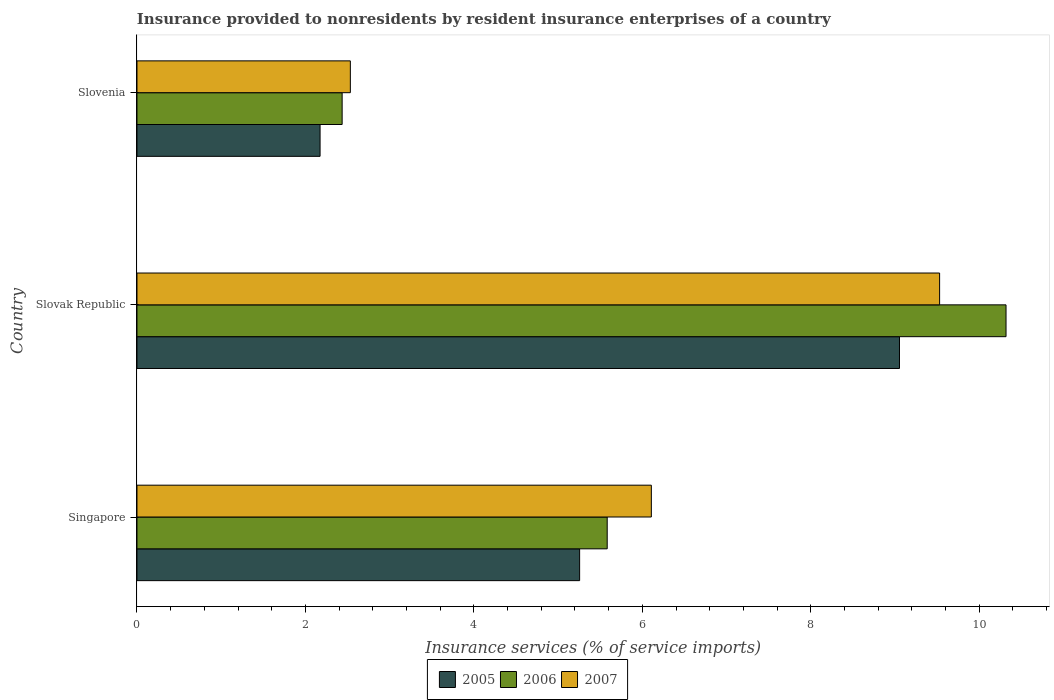How many different coloured bars are there?
Offer a very short reply. 3. How many groups of bars are there?
Ensure brevity in your answer.  3. How many bars are there on the 2nd tick from the top?
Provide a succinct answer. 3. What is the label of the 2nd group of bars from the top?
Offer a very short reply. Slovak Republic. In how many cases, is the number of bars for a given country not equal to the number of legend labels?
Make the answer very short. 0. What is the insurance provided to nonresidents in 2006 in Slovenia?
Your answer should be compact. 2.44. Across all countries, what is the maximum insurance provided to nonresidents in 2005?
Your answer should be compact. 9.05. Across all countries, what is the minimum insurance provided to nonresidents in 2005?
Provide a short and direct response. 2.17. In which country was the insurance provided to nonresidents in 2006 maximum?
Give a very brief answer. Slovak Republic. In which country was the insurance provided to nonresidents in 2006 minimum?
Your response must be concise. Slovenia. What is the total insurance provided to nonresidents in 2007 in the graph?
Ensure brevity in your answer.  18.17. What is the difference between the insurance provided to nonresidents in 2005 in Singapore and that in Slovenia?
Ensure brevity in your answer.  3.08. What is the difference between the insurance provided to nonresidents in 2006 in Singapore and the insurance provided to nonresidents in 2007 in Slovenia?
Offer a very short reply. 3.05. What is the average insurance provided to nonresidents in 2007 per country?
Ensure brevity in your answer.  6.06. What is the difference between the insurance provided to nonresidents in 2007 and insurance provided to nonresidents in 2006 in Slovak Republic?
Your answer should be very brief. -0.79. What is the ratio of the insurance provided to nonresidents in 2005 in Slovak Republic to that in Slovenia?
Provide a short and direct response. 4.16. Is the difference between the insurance provided to nonresidents in 2007 in Singapore and Slovenia greater than the difference between the insurance provided to nonresidents in 2006 in Singapore and Slovenia?
Give a very brief answer. Yes. What is the difference between the highest and the second highest insurance provided to nonresidents in 2006?
Provide a short and direct response. 4.74. What is the difference between the highest and the lowest insurance provided to nonresidents in 2005?
Offer a very short reply. 6.88. Is the sum of the insurance provided to nonresidents in 2007 in Singapore and Slovak Republic greater than the maximum insurance provided to nonresidents in 2006 across all countries?
Your answer should be compact. Yes. What does the 2nd bar from the top in Singapore represents?
Offer a terse response. 2006. What does the 3rd bar from the bottom in Slovak Republic represents?
Offer a very short reply. 2007. Where does the legend appear in the graph?
Ensure brevity in your answer.  Bottom center. How many legend labels are there?
Offer a very short reply. 3. How are the legend labels stacked?
Offer a terse response. Horizontal. What is the title of the graph?
Give a very brief answer. Insurance provided to nonresidents by resident insurance enterprises of a country. Does "2005" appear as one of the legend labels in the graph?
Your answer should be compact. Yes. What is the label or title of the X-axis?
Keep it short and to the point. Insurance services (% of service imports). What is the Insurance services (% of service imports) of 2005 in Singapore?
Ensure brevity in your answer.  5.26. What is the Insurance services (% of service imports) of 2006 in Singapore?
Provide a succinct answer. 5.58. What is the Insurance services (% of service imports) in 2007 in Singapore?
Provide a succinct answer. 6.11. What is the Insurance services (% of service imports) of 2005 in Slovak Republic?
Provide a short and direct response. 9.05. What is the Insurance services (% of service imports) in 2006 in Slovak Republic?
Your answer should be very brief. 10.32. What is the Insurance services (% of service imports) of 2007 in Slovak Republic?
Make the answer very short. 9.53. What is the Insurance services (% of service imports) of 2005 in Slovenia?
Ensure brevity in your answer.  2.17. What is the Insurance services (% of service imports) in 2006 in Slovenia?
Ensure brevity in your answer.  2.44. What is the Insurance services (% of service imports) of 2007 in Slovenia?
Provide a succinct answer. 2.53. Across all countries, what is the maximum Insurance services (% of service imports) of 2005?
Provide a short and direct response. 9.05. Across all countries, what is the maximum Insurance services (% of service imports) of 2006?
Ensure brevity in your answer.  10.32. Across all countries, what is the maximum Insurance services (% of service imports) of 2007?
Keep it short and to the point. 9.53. Across all countries, what is the minimum Insurance services (% of service imports) in 2005?
Give a very brief answer. 2.17. Across all countries, what is the minimum Insurance services (% of service imports) of 2006?
Your response must be concise. 2.44. Across all countries, what is the minimum Insurance services (% of service imports) in 2007?
Give a very brief answer. 2.53. What is the total Insurance services (% of service imports) of 2005 in the graph?
Offer a very short reply. 16.48. What is the total Insurance services (% of service imports) in 2006 in the graph?
Offer a terse response. 18.34. What is the total Insurance services (% of service imports) in 2007 in the graph?
Provide a succinct answer. 18.17. What is the difference between the Insurance services (% of service imports) in 2005 in Singapore and that in Slovak Republic?
Ensure brevity in your answer.  -3.8. What is the difference between the Insurance services (% of service imports) in 2006 in Singapore and that in Slovak Republic?
Your response must be concise. -4.74. What is the difference between the Insurance services (% of service imports) in 2007 in Singapore and that in Slovak Republic?
Keep it short and to the point. -3.42. What is the difference between the Insurance services (% of service imports) in 2005 in Singapore and that in Slovenia?
Provide a succinct answer. 3.08. What is the difference between the Insurance services (% of service imports) of 2006 in Singapore and that in Slovenia?
Your response must be concise. 3.15. What is the difference between the Insurance services (% of service imports) of 2007 in Singapore and that in Slovenia?
Your response must be concise. 3.57. What is the difference between the Insurance services (% of service imports) in 2005 in Slovak Republic and that in Slovenia?
Keep it short and to the point. 6.88. What is the difference between the Insurance services (% of service imports) of 2006 in Slovak Republic and that in Slovenia?
Make the answer very short. 7.88. What is the difference between the Insurance services (% of service imports) in 2007 in Slovak Republic and that in Slovenia?
Offer a very short reply. 7. What is the difference between the Insurance services (% of service imports) in 2005 in Singapore and the Insurance services (% of service imports) in 2006 in Slovak Republic?
Offer a terse response. -5.06. What is the difference between the Insurance services (% of service imports) in 2005 in Singapore and the Insurance services (% of service imports) in 2007 in Slovak Republic?
Ensure brevity in your answer.  -4.27. What is the difference between the Insurance services (% of service imports) of 2006 in Singapore and the Insurance services (% of service imports) of 2007 in Slovak Republic?
Offer a terse response. -3.95. What is the difference between the Insurance services (% of service imports) of 2005 in Singapore and the Insurance services (% of service imports) of 2006 in Slovenia?
Provide a short and direct response. 2.82. What is the difference between the Insurance services (% of service imports) in 2005 in Singapore and the Insurance services (% of service imports) in 2007 in Slovenia?
Provide a short and direct response. 2.72. What is the difference between the Insurance services (% of service imports) in 2006 in Singapore and the Insurance services (% of service imports) in 2007 in Slovenia?
Your answer should be very brief. 3.05. What is the difference between the Insurance services (% of service imports) in 2005 in Slovak Republic and the Insurance services (% of service imports) in 2006 in Slovenia?
Keep it short and to the point. 6.62. What is the difference between the Insurance services (% of service imports) in 2005 in Slovak Republic and the Insurance services (% of service imports) in 2007 in Slovenia?
Provide a short and direct response. 6.52. What is the difference between the Insurance services (% of service imports) in 2006 in Slovak Republic and the Insurance services (% of service imports) in 2007 in Slovenia?
Your response must be concise. 7.79. What is the average Insurance services (% of service imports) in 2005 per country?
Your answer should be compact. 5.49. What is the average Insurance services (% of service imports) of 2006 per country?
Provide a short and direct response. 6.11. What is the average Insurance services (% of service imports) in 2007 per country?
Your answer should be very brief. 6.06. What is the difference between the Insurance services (% of service imports) in 2005 and Insurance services (% of service imports) in 2006 in Singapore?
Your answer should be compact. -0.33. What is the difference between the Insurance services (% of service imports) of 2005 and Insurance services (% of service imports) of 2007 in Singapore?
Your response must be concise. -0.85. What is the difference between the Insurance services (% of service imports) in 2006 and Insurance services (% of service imports) in 2007 in Singapore?
Your response must be concise. -0.52. What is the difference between the Insurance services (% of service imports) of 2005 and Insurance services (% of service imports) of 2006 in Slovak Republic?
Offer a very short reply. -1.27. What is the difference between the Insurance services (% of service imports) of 2005 and Insurance services (% of service imports) of 2007 in Slovak Republic?
Ensure brevity in your answer.  -0.48. What is the difference between the Insurance services (% of service imports) in 2006 and Insurance services (% of service imports) in 2007 in Slovak Republic?
Your answer should be compact. 0.79. What is the difference between the Insurance services (% of service imports) in 2005 and Insurance services (% of service imports) in 2006 in Slovenia?
Give a very brief answer. -0.26. What is the difference between the Insurance services (% of service imports) of 2005 and Insurance services (% of service imports) of 2007 in Slovenia?
Give a very brief answer. -0.36. What is the difference between the Insurance services (% of service imports) in 2006 and Insurance services (% of service imports) in 2007 in Slovenia?
Offer a very short reply. -0.1. What is the ratio of the Insurance services (% of service imports) of 2005 in Singapore to that in Slovak Republic?
Offer a terse response. 0.58. What is the ratio of the Insurance services (% of service imports) of 2006 in Singapore to that in Slovak Republic?
Provide a succinct answer. 0.54. What is the ratio of the Insurance services (% of service imports) in 2007 in Singapore to that in Slovak Republic?
Keep it short and to the point. 0.64. What is the ratio of the Insurance services (% of service imports) of 2005 in Singapore to that in Slovenia?
Your answer should be compact. 2.42. What is the ratio of the Insurance services (% of service imports) of 2006 in Singapore to that in Slovenia?
Your answer should be compact. 2.29. What is the ratio of the Insurance services (% of service imports) in 2007 in Singapore to that in Slovenia?
Give a very brief answer. 2.41. What is the ratio of the Insurance services (% of service imports) of 2005 in Slovak Republic to that in Slovenia?
Keep it short and to the point. 4.16. What is the ratio of the Insurance services (% of service imports) in 2006 in Slovak Republic to that in Slovenia?
Offer a terse response. 4.24. What is the ratio of the Insurance services (% of service imports) in 2007 in Slovak Republic to that in Slovenia?
Offer a terse response. 3.76. What is the difference between the highest and the second highest Insurance services (% of service imports) in 2005?
Keep it short and to the point. 3.8. What is the difference between the highest and the second highest Insurance services (% of service imports) in 2006?
Make the answer very short. 4.74. What is the difference between the highest and the second highest Insurance services (% of service imports) in 2007?
Your answer should be compact. 3.42. What is the difference between the highest and the lowest Insurance services (% of service imports) in 2005?
Make the answer very short. 6.88. What is the difference between the highest and the lowest Insurance services (% of service imports) in 2006?
Your response must be concise. 7.88. What is the difference between the highest and the lowest Insurance services (% of service imports) in 2007?
Offer a very short reply. 7. 